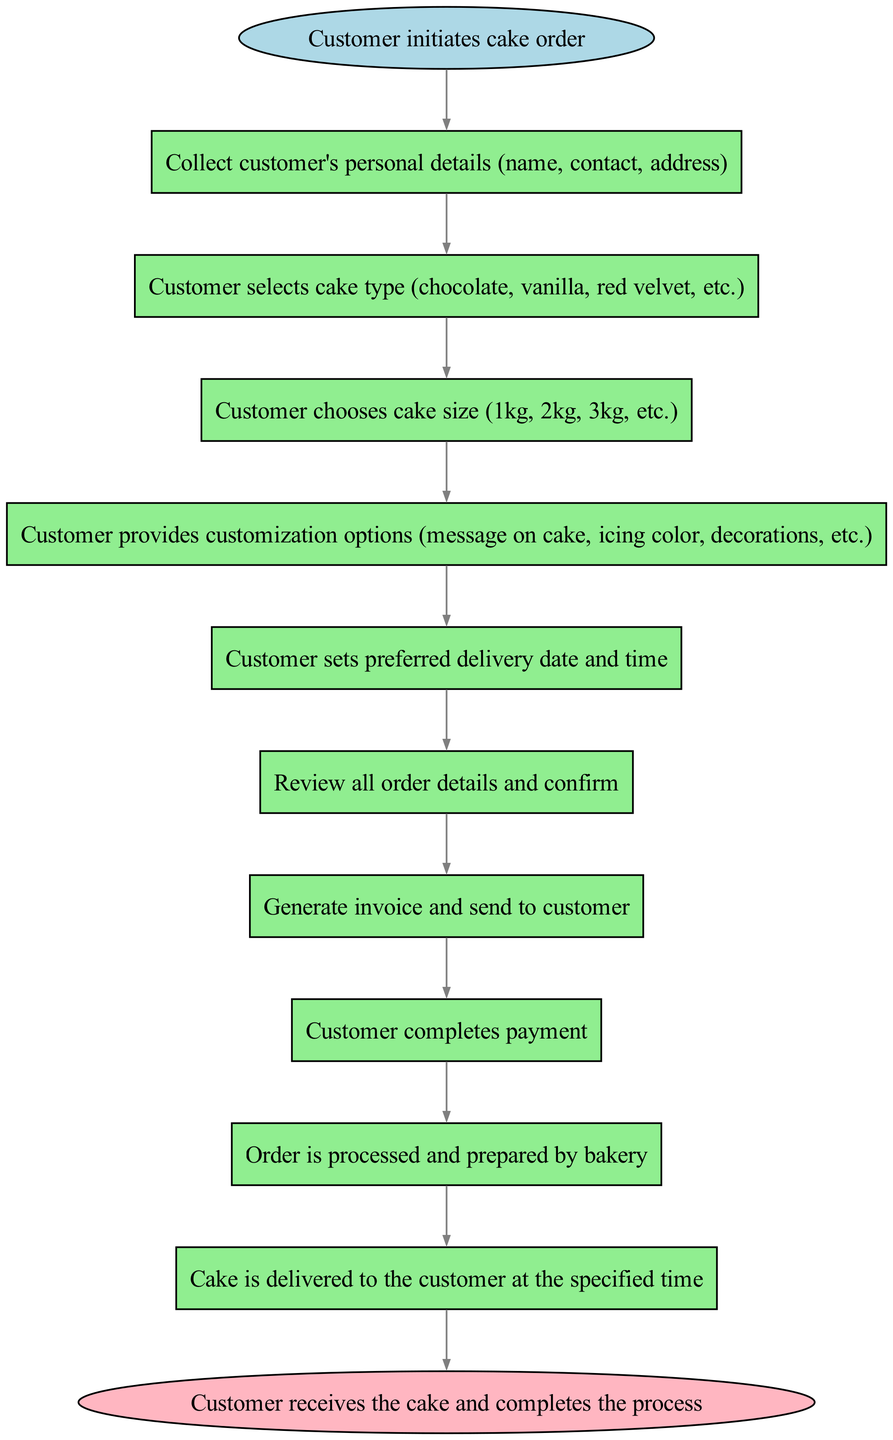What is the first step in the cake ordering process? The first step, indicated by the starting node, is "Customer initiates cake order." This is the initial action that begins the entire procedure, leading to the collection of customer details.
Answer: Customer initiates cake order How many steps are there in the cake ordering procedure? By counting each individual step listed in the diagram, we find there are ten steps in total, from collecting customer details to cake delivery.
Answer: ten What does the customer select after choosing the cake type? After selecting the cake type, the next step for the customer is to choose the cake size. This can be traced in the flow from choosing the cake type to selecting the cake size.
Answer: cake size Which step comes just before payment? The step that comes directly before payment is "Generate invoice and send to customer." This shows the direct connection in the flow leading to the payment step.
Answer: Generate invoice and send to customer What is the final outcome of the cake ordering process? The last node in the flow chart describes the final outcome, which is "Customer receives the cake and completes the process." This signifies the conclusion of the entire procedure.
Answer: Customer receives the cake and completes the process If the customer skips to customization options, what step will they be missing? If the customer skips directly to customization options, they will miss the step "select_cake_size." The flow indicates that customization options cannot be accessed without first selecting a cake size.
Answer: select_cake_size What follows after the customer sets the delivery time? After setting the delivery time, the customer will proceed to confirm the order. This shows the logical sequence following the delivery time setting.
Answer: confirm order How does the process begin? The process begins with the action of the customer initiating a cake order, as shown in the first node of the diagram. This is the starting point leading to subsequent actions.
Answer: Customer initiates cake order 